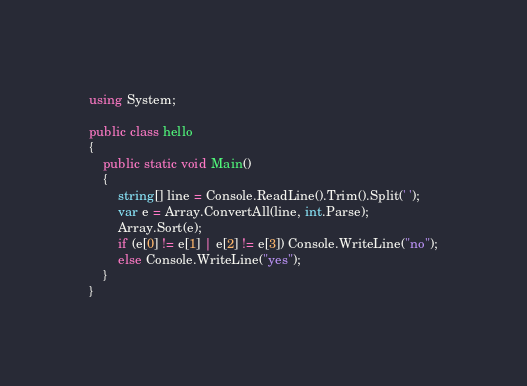Convert code to text. <code><loc_0><loc_0><loc_500><loc_500><_C#_>using System;

public class hello
{
    public static void Main()
    {
        string[] line = Console.ReadLine().Trim().Split(' ');
        var e = Array.ConvertAll(line, int.Parse);
        Array.Sort(e);
        if (e[0] != e[1] | e[2] != e[3]) Console.WriteLine("no");
        else Console.WriteLine("yes");
    }
}</code> 